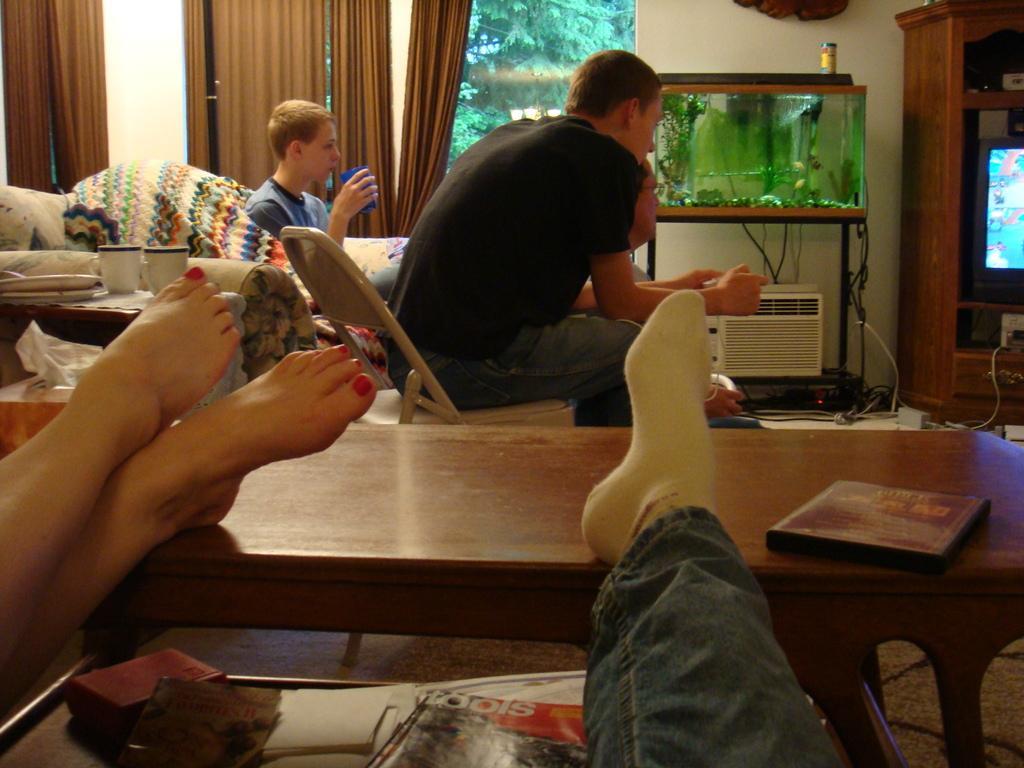In one or two sentences, can you explain what this image depicts? In this image there are three persons who are sitting and in the bottom there are two persons and on the background there is a window and some curtains are there. And on the top of the right side there is one aquarium and one air cooler is there and on the right side there is one television and in the bottom there is one table. On that table there is one book and on the left side there is another table and some books are there. On the table and on the top there is a wall and some wires are there on the floor. 